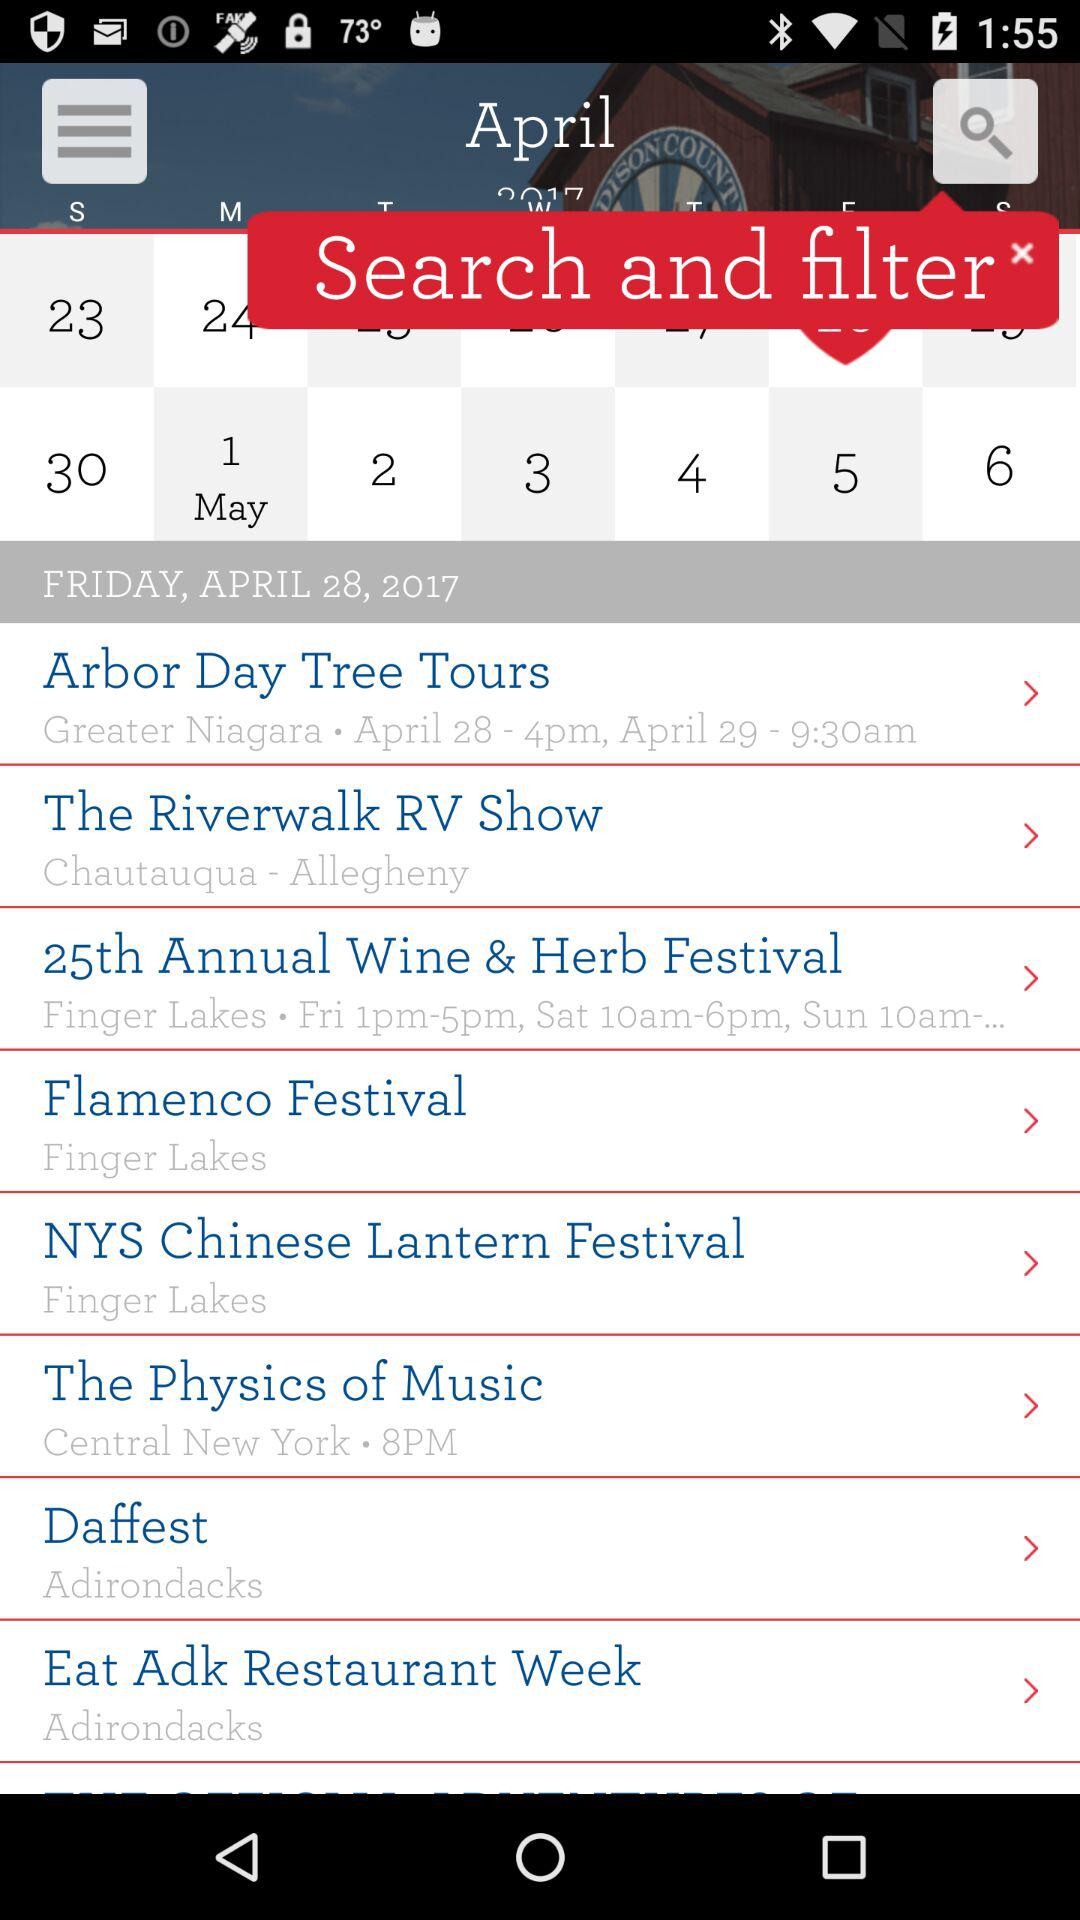What is the name of the event held at Greater Niagara? The name of the event held at Greater Niagara is "Arbor Day Tree Tours". 